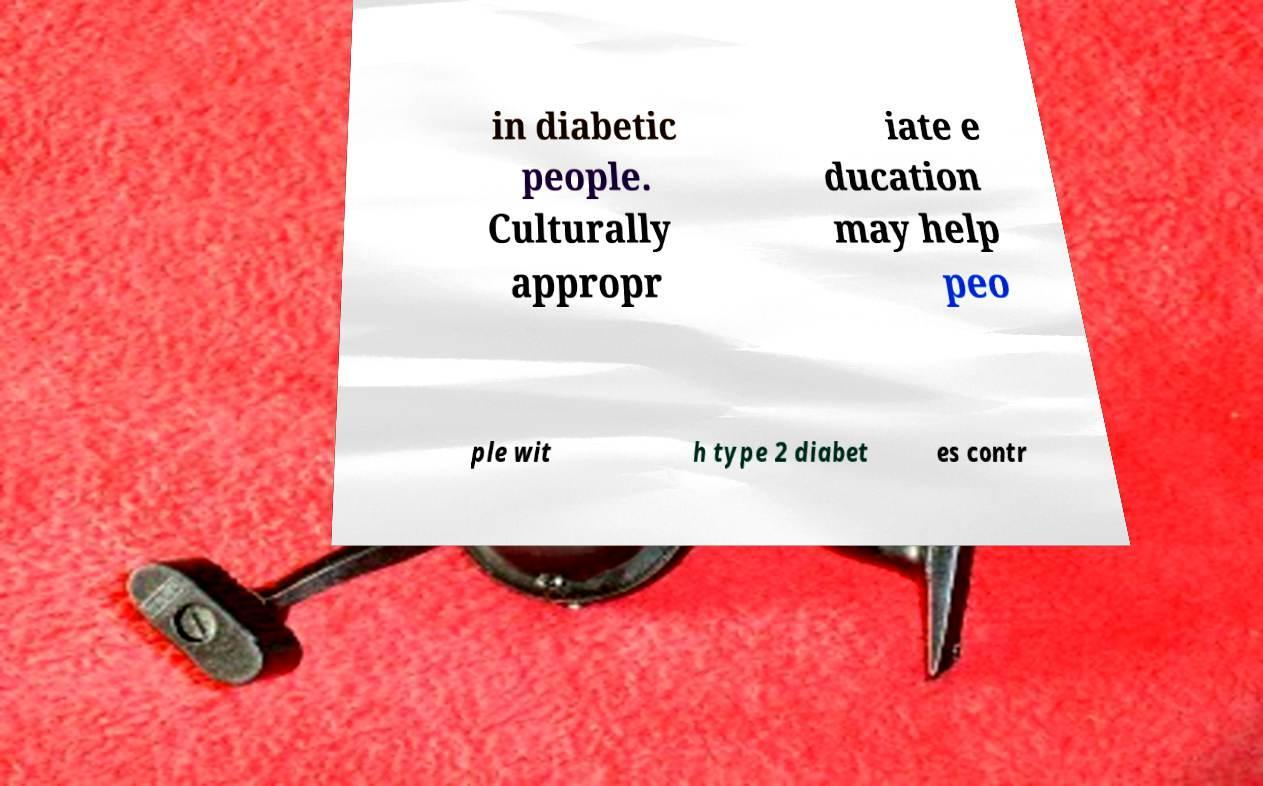Please read and relay the text visible in this image. What does it say? in diabetic people. Culturally appropr iate e ducation may help peo ple wit h type 2 diabet es contr 